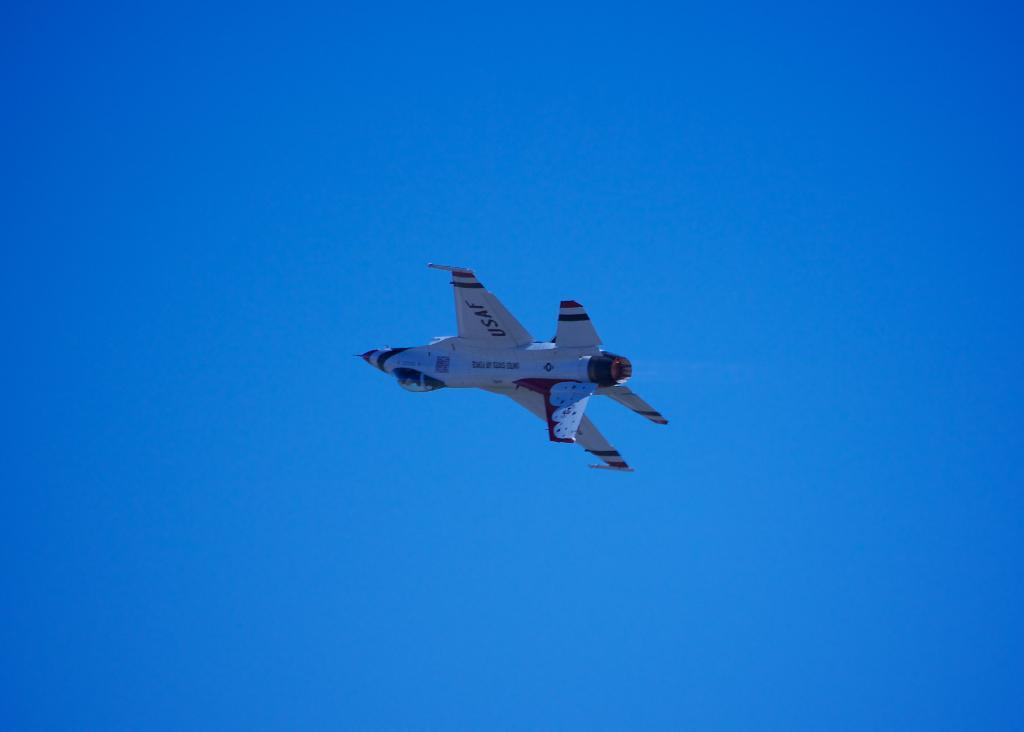What is the main subject of the picture? The main subject of the picture is an aircraft. What is the aircraft doing in the picture? The aircraft is flying in the sky. What type of glove is being used by the aircraft in the image? There is no glove present in the image, as the subject is an aircraft flying in the sky. What type of business is being conducted by the aircraft in the image? The image does not provide information about any business being conducted by the aircraft. 